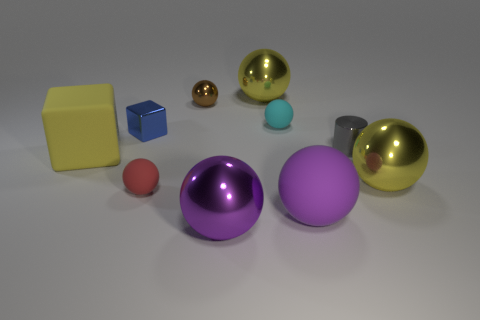Subtract all big matte balls. How many balls are left? 6 Subtract 1 cylinders. How many cylinders are left? 0 Subtract all purple blocks. How many gray balls are left? 0 Subtract all big cubes. Subtract all yellow blocks. How many objects are left? 8 Add 2 big purple metal things. How many big purple metal things are left? 3 Add 8 tiny red matte balls. How many tiny red matte balls exist? 9 Subtract all blue cubes. How many cubes are left? 1 Subtract 0 gray spheres. How many objects are left? 10 Subtract all cylinders. How many objects are left? 9 Subtract all red blocks. Subtract all red cylinders. How many blocks are left? 2 